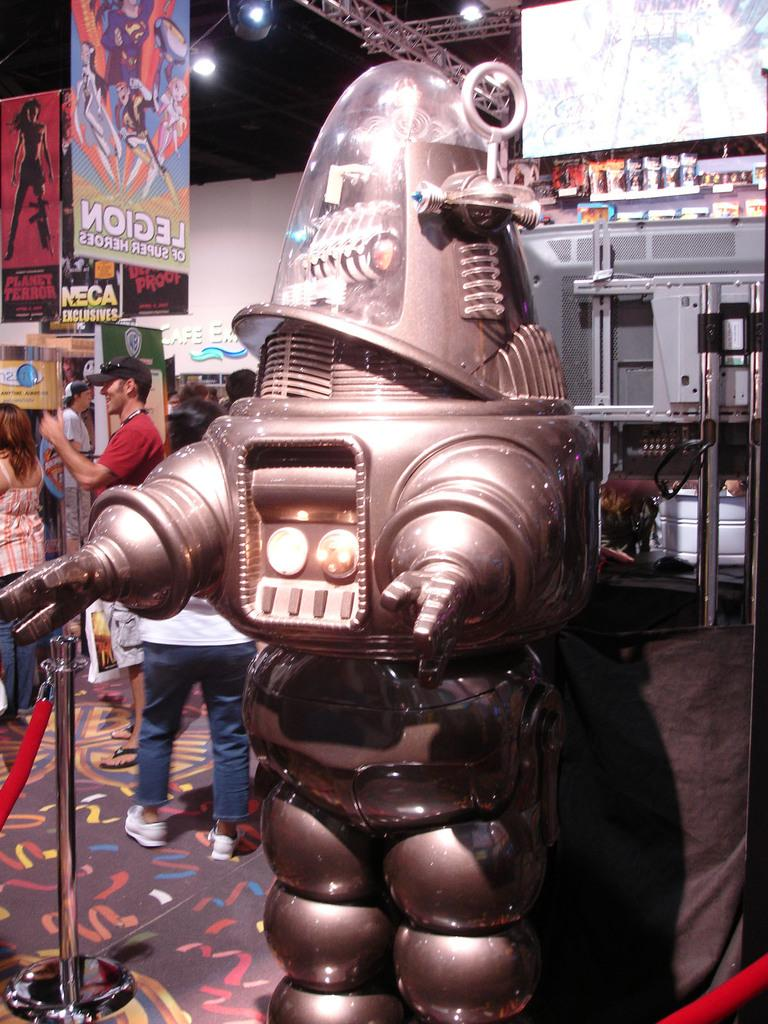What is the main subject of the image? There is a robot in the image. What can be seen in the background of the image? There are persons, banners, and a machine in the background of the image. How many clovers are visible on the robot in the image? There are no clovers present on the robot in the image. What type of oven is being used by the crow in the image? There is no oven or crow present in the image. 